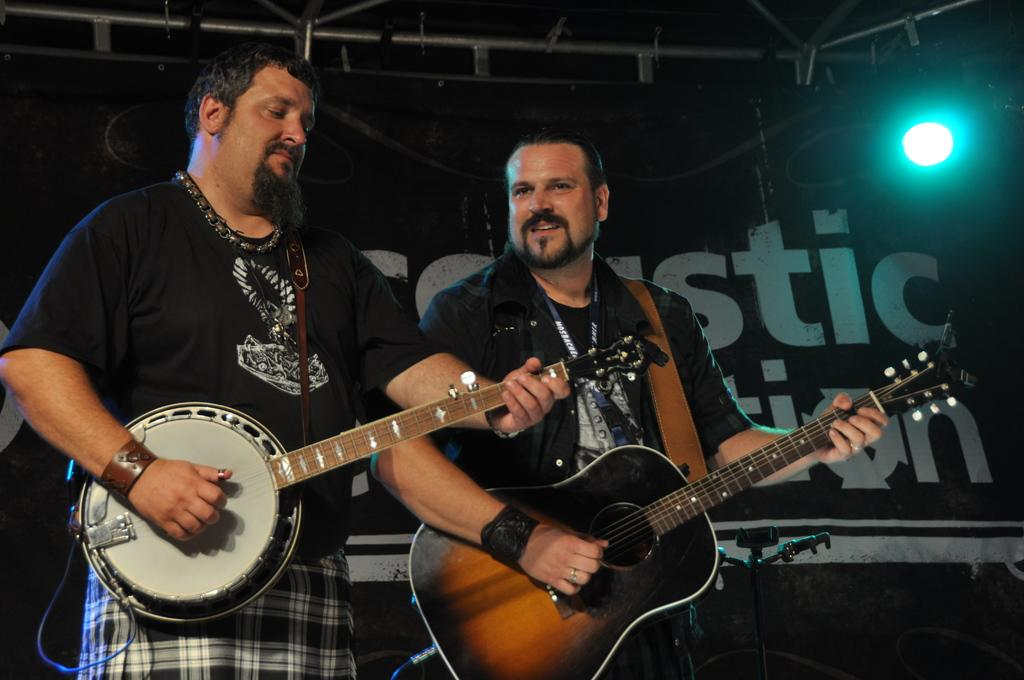How many people are in the image? There are two persons in the image. What are the persons doing in the image? The persons are standing and holding a guitar in their hands. Can you describe the lighting in the image? There is a light in the right top corner of the image. What book is the person reading in the image? There is no book present in the image; the persons are holding a guitar. How many chairs are visible in the image? There are no chairs visible in the image. 